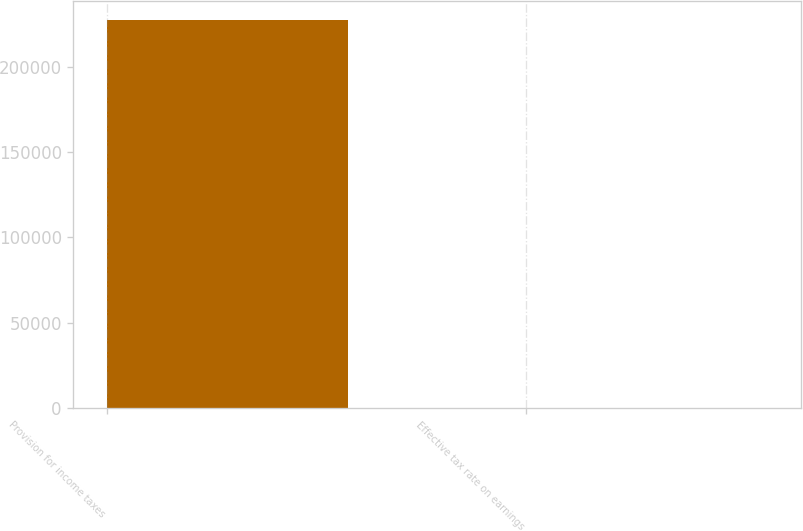Convert chart. <chart><loc_0><loc_0><loc_500><loc_500><bar_chart><fcel>Provision for income taxes<fcel>Effective tax rate on earnings<nl><fcel>227242<fcel>36<nl></chart> 